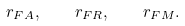<formula> <loc_0><loc_0><loc_500><loc_500>r _ { F A } , \quad r _ { F R } , \quad r _ { F M } .</formula> 